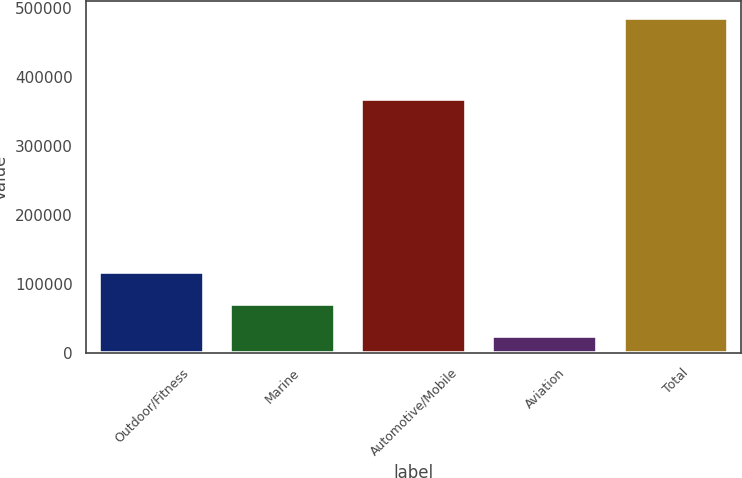Convert chart to OTSL. <chart><loc_0><loc_0><loc_500><loc_500><bar_chart><fcel>Outdoor/Fitness<fcel>Marine<fcel>Automotive/Mobile<fcel>Aviation<fcel>Total<nl><fcel>116845<fcel>70777<fcel>367880<fcel>24709<fcel>485389<nl></chart> 